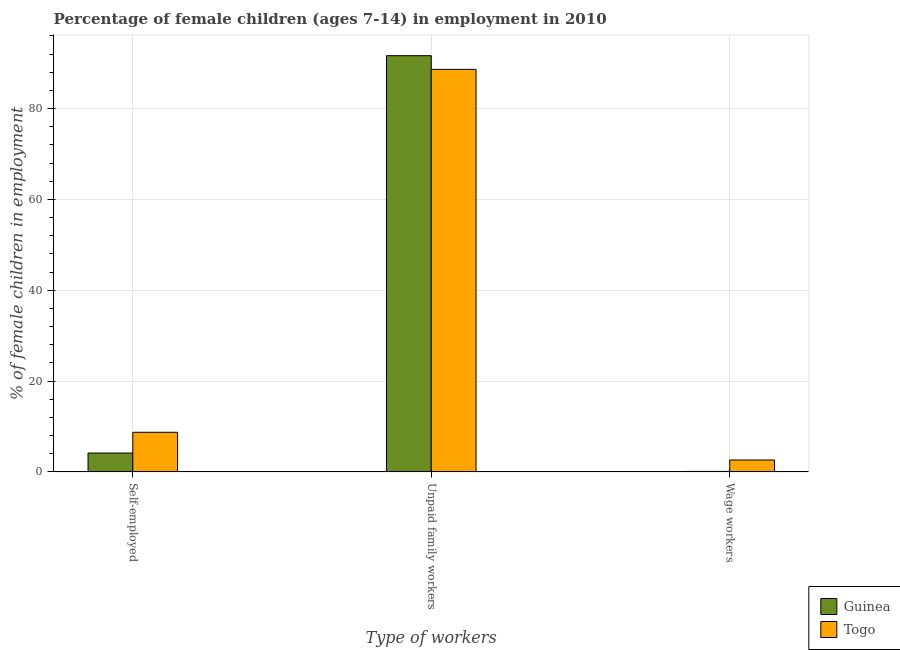What is the label of the 2nd group of bars from the left?
Offer a very short reply. Unpaid family workers. What is the percentage of children employed as wage workers in Togo?
Provide a short and direct response. 2.63. Across all countries, what is the maximum percentage of children employed as unpaid family workers?
Your response must be concise. 91.65. Across all countries, what is the minimum percentage of children employed as wage workers?
Keep it short and to the point. 0.11. In which country was the percentage of children employed as wage workers maximum?
Ensure brevity in your answer.  Togo. In which country was the percentage of children employed as wage workers minimum?
Offer a very short reply. Guinea. What is the total percentage of self employed children in the graph?
Your answer should be compact. 12.89. What is the difference between the percentage of self employed children in Guinea and that in Togo?
Keep it short and to the point. -4.57. What is the difference between the percentage of self employed children in Togo and the percentage of children employed as unpaid family workers in Guinea?
Provide a short and direct response. -82.92. What is the average percentage of self employed children per country?
Offer a very short reply. 6.45. What is the difference between the percentage of self employed children and percentage of children employed as wage workers in Togo?
Provide a succinct answer. 6.1. In how many countries, is the percentage of children employed as wage workers greater than 92 %?
Offer a very short reply. 0. What is the ratio of the percentage of children employed as wage workers in Guinea to that in Togo?
Offer a very short reply. 0.04. What is the difference between the highest and the second highest percentage of children employed as unpaid family workers?
Give a very brief answer. 3.01. What is the difference between the highest and the lowest percentage of self employed children?
Make the answer very short. 4.57. In how many countries, is the percentage of children employed as unpaid family workers greater than the average percentage of children employed as unpaid family workers taken over all countries?
Your answer should be very brief. 1. What does the 1st bar from the left in Self-employed represents?
Give a very brief answer. Guinea. What does the 1st bar from the right in Self-employed represents?
Give a very brief answer. Togo. Are all the bars in the graph horizontal?
Your answer should be very brief. No. Does the graph contain any zero values?
Your answer should be compact. No. Where does the legend appear in the graph?
Ensure brevity in your answer.  Bottom right. How many legend labels are there?
Keep it short and to the point. 2. What is the title of the graph?
Keep it short and to the point. Percentage of female children (ages 7-14) in employment in 2010. Does "St. Kitts and Nevis" appear as one of the legend labels in the graph?
Provide a succinct answer. No. What is the label or title of the X-axis?
Provide a succinct answer. Type of workers. What is the label or title of the Y-axis?
Provide a succinct answer. % of female children in employment. What is the % of female children in employment of Guinea in Self-employed?
Your answer should be compact. 4.16. What is the % of female children in employment in Togo in Self-employed?
Offer a terse response. 8.73. What is the % of female children in employment of Guinea in Unpaid family workers?
Provide a short and direct response. 91.65. What is the % of female children in employment in Togo in Unpaid family workers?
Provide a succinct answer. 88.64. What is the % of female children in employment in Guinea in Wage workers?
Provide a short and direct response. 0.11. What is the % of female children in employment in Togo in Wage workers?
Give a very brief answer. 2.63. Across all Type of workers, what is the maximum % of female children in employment in Guinea?
Your answer should be very brief. 91.65. Across all Type of workers, what is the maximum % of female children in employment of Togo?
Offer a very short reply. 88.64. Across all Type of workers, what is the minimum % of female children in employment in Guinea?
Provide a short and direct response. 0.11. Across all Type of workers, what is the minimum % of female children in employment in Togo?
Provide a short and direct response. 2.63. What is the total % of female children in employment in Guinea in the graph?
Ensure brevity in your answer.  95.92. What is the difference between the % of female children in employment of Guinea in Self-employed and that in Unpaid family workers?
Ensure brevity in your answer.  -87.49. What is the difference between the % of female children in employment of Togo in Self-employed and that in Unpaid family workers?
Offer a terse response. -79.91. What is the difference between the % of female children in employment of Guinea in Self-employed and that in Wage workers?
Provide a succinct answer. 4.05. What is the difference between the % of female children in employment in Guinea in Unpaid family workers and that in Wage workers?
Make the answer very short. 91.54. What is the difference between the % of female children in employment in Togo in Unpaid family workers and that in Wage workers?
Your answer should be very brief. 86.01. What is the difference between the % of female children in employment in Guinea in Self-employed and the % of female children in employment in Togo in Unpaid family workers?
Your answer should be compact. -84.48. What is the difference between the % of female children in employment of Guinea in Self-employed and the % of female children in employment of Togo in Wage workers?
Offer a very short reply. 1.53. What is the difference between the % of female children in employment in Guinea in Unpaid family workers and the % of female children in employment in Togo in Wage workers?
Offer a very short reply. 89.02. What is the average % of female children in employment of Guinea per Type of workers?
Your answer should be very brief. 31.97. What is the average % of female children in employment of Togo per Type of workers?
Keep it short and to the point. 33.33. What is the difference between the % of female children in employment in Guinea and % of female children in employment in Togo in Self-employed?
Your answer should be very brief. -4.57. What is the difference between the % of female children in employment of Guinea and % of female children in employment of Togo in Unpaid family workers?
Your response must be concise. 3.01. What is the difference between the % of female children in employment of Guinea and % of female children in employment of Togo in Wage workers?
Keep it short and to the point. -2.52. What is the ratio of the % of female children in employment of Guinea in Self-employed to that in Unpaid family workers?
Your response must be concise. 0.05. What is the ratio of the % of female children in employment of Togo in Self-employed to that in Unpaid family workers?
Keep it short and to the point. 0.1. What is the ratio of the % of female children in employment in Guinea in Self-employed to that in Wage workers?
Make the answer very short. 37.82. What is the ratio of the % of female children in employment of Togo in Self-employed to that in Wage workers?
Give a very brief answer. 3.32. What is the ratio of the % of female children in employment in Guinea in Unpaid family workers to that in Wage workers?
Keep it short and to the point. 833.18. What is the ratio of the % of female children in employment in Togo in Unpaid family workers to that in Wage workers?
Your response must be concise. 33.7. What is the difference between the highest and the second highest % of female children in employment in Guinea?
Provide a short and direct response. 87.49. What is the difference between the highest and the second highest % of female children in employment in Togo?
Make the answer very short. 79.91. What is the difference between the highest and the lowest % of female children in employment of Guinea?
Offer a terse response. 91.54. What is the difference between the highest and the lowest % of female children in employment in Togo?
Your answer should be very brief. 86.01. 